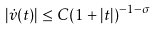Convert formula to latex. <formula><loc_0><loc_0><loc_500><loc_500>| \dot { v } ( t ) | \leq C ( 1 + | t | ) ^ { - 1 - \sigma }</formula> 